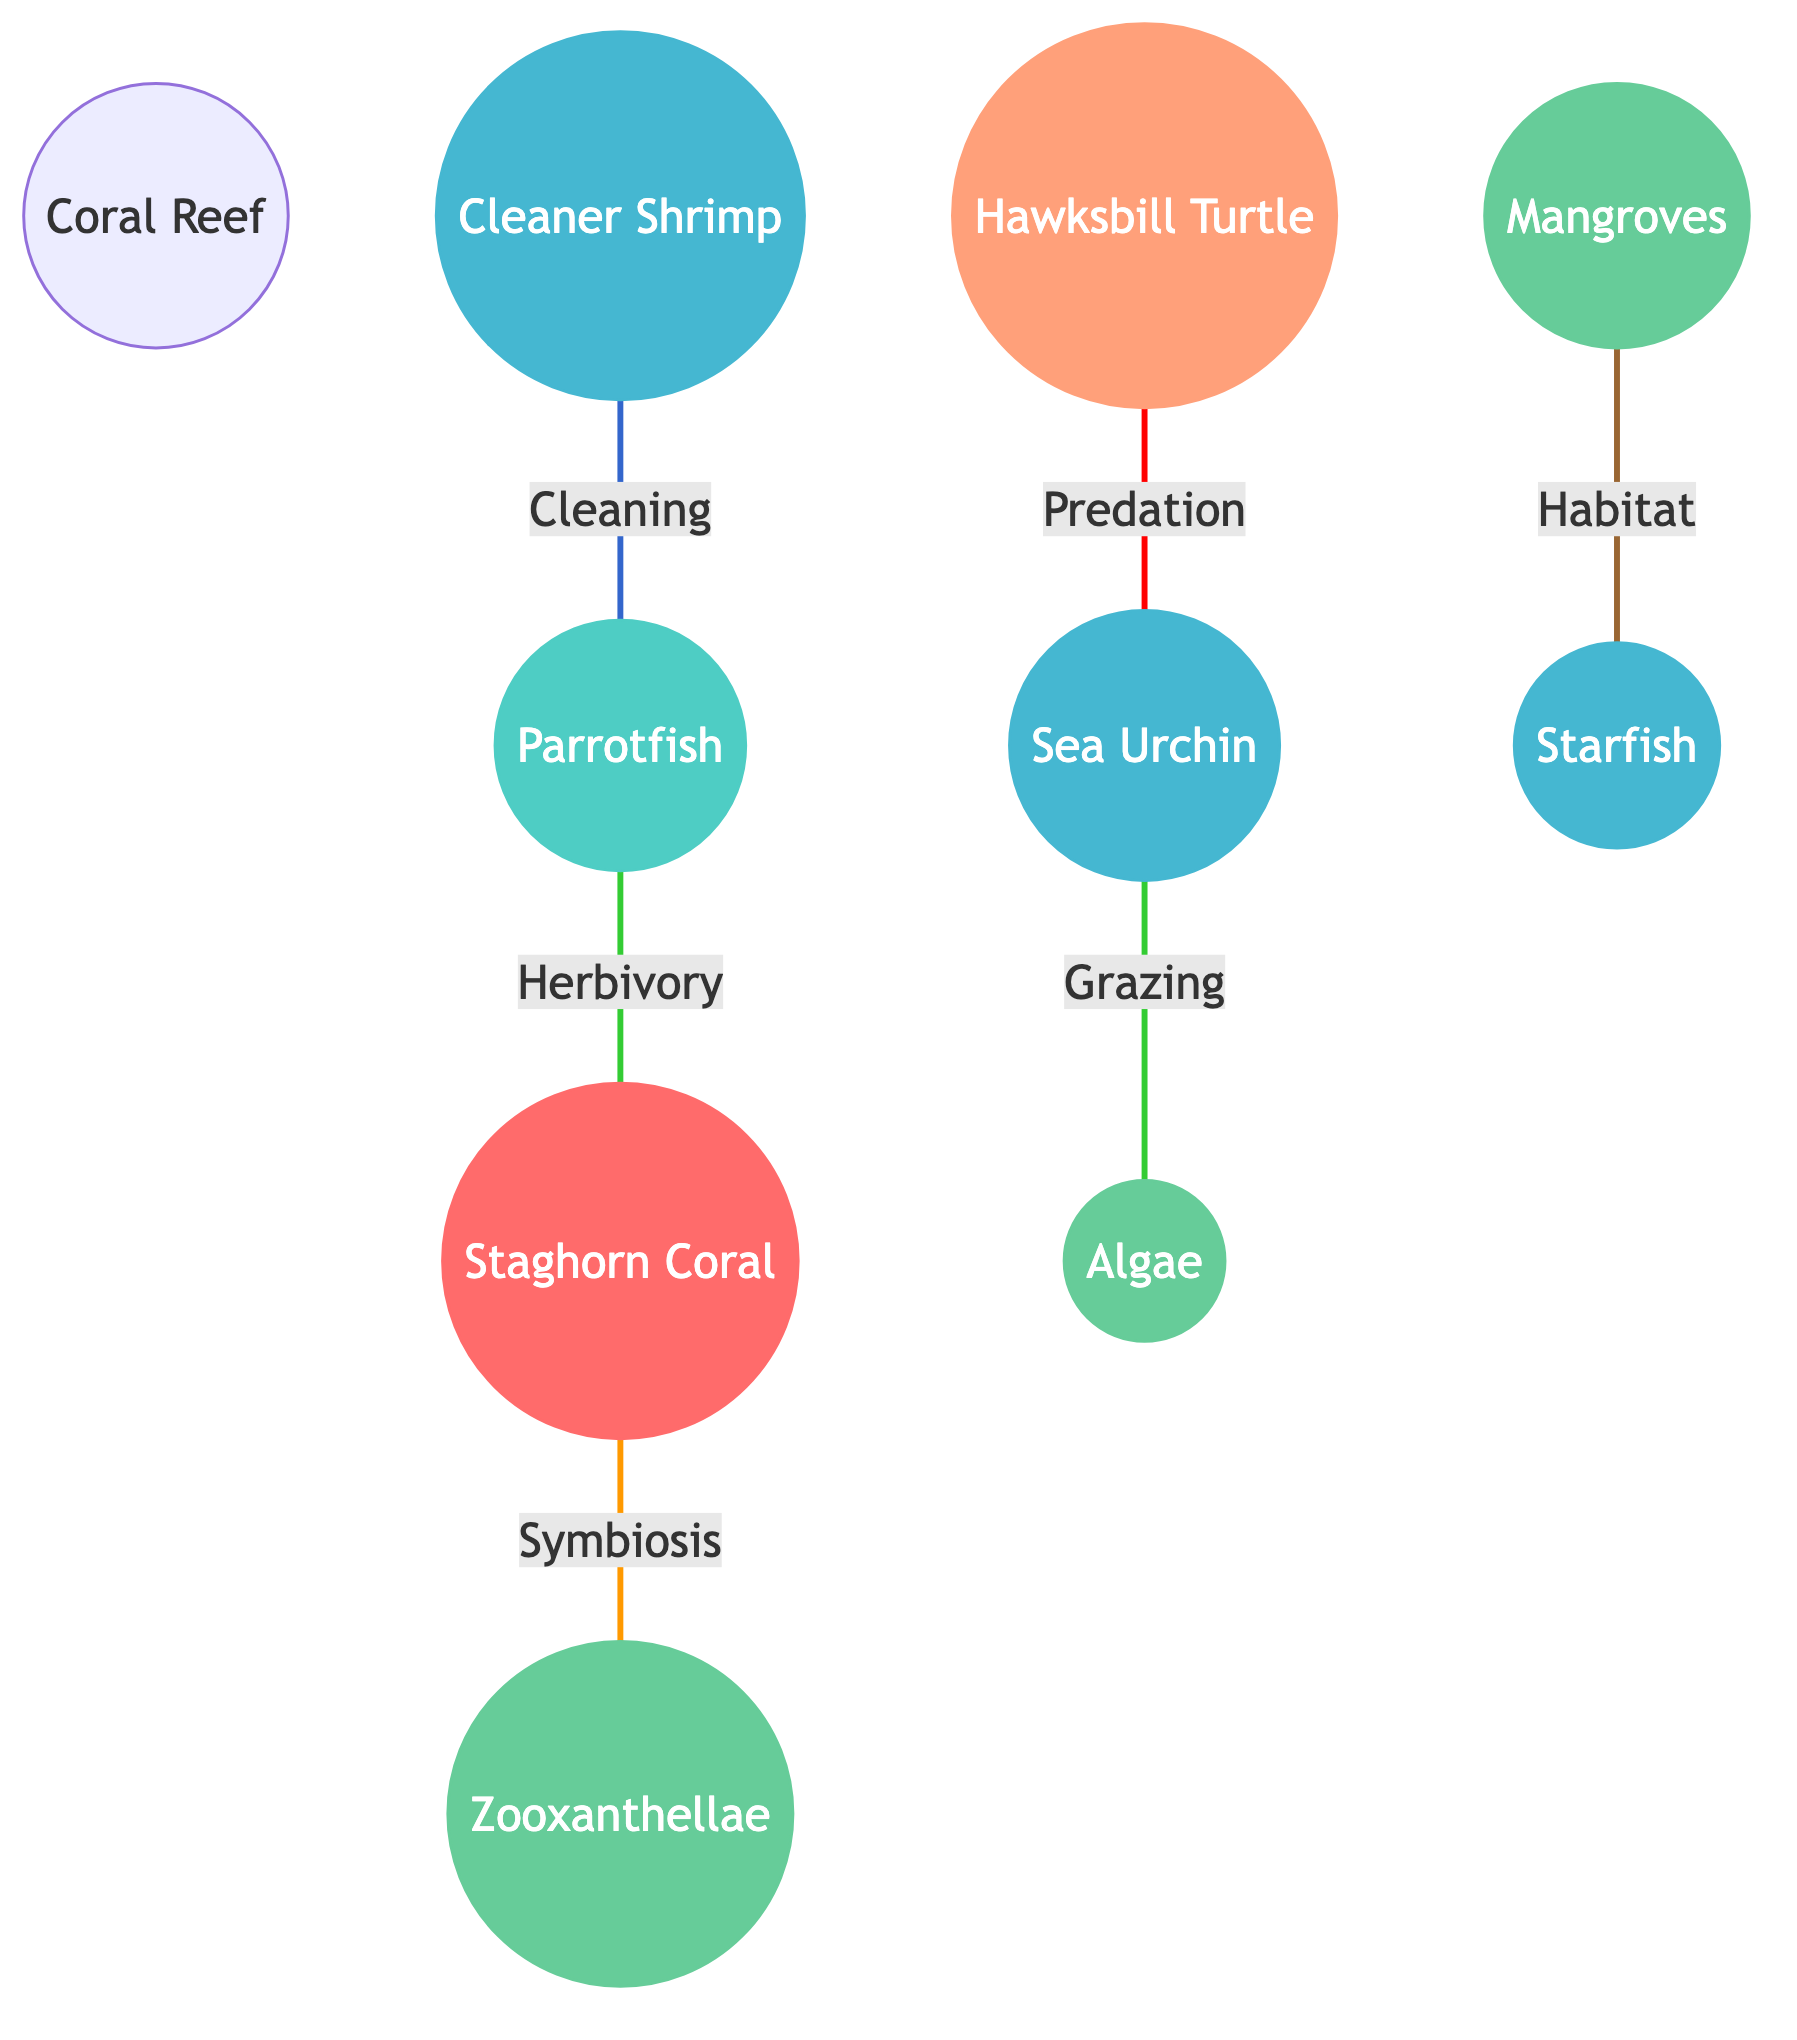What types of organisms are represented in the coral reef ecosystem? The diagram includes corals, fish, invertebrates, plants, and reptiles, indicating the diversity of organisms present in the coral reef ecosystem.
Answer: corals, fish, invertebrates, plants, reptiles How many primary plants are featured in the diagram? The diagram shows three primary plant species: Zooxanthellae, Mangroves, and Algae. By counting these nodes, we find there are three plants.
Answer: 3 What is the relationship between Staghorn Coral and Zooxanthellae? The diagram indicates that the relationship is Symbiosis. This connection highlights the mutual benefits gained by both the coral and the zooxanthellae.
Answer: Symbiosis Which organism preys on the Sea Urchin? The diagram shows the Hawksbill Turtle connected to the Sea Urchin through the relationship Predation, indicating that Hawksbill Turtles consume Sea Urchins.
Answer: Hawksbill Turtle How many total species interactions are depicted in the diagram? There are six interactions represented: Symbiosis, Herbivory, Grazing, Predation, Habitat, and Cleaning. By counting these connections from the various organisms, we confirm there are six interactions.
Answer: 6 What type of interaction do Cleaner Shrimp have with Parrotfish? The diagram illustrates the interaction as Cleaning, indicating that Cleaner Shrimp help Parrotfish by removing parasites or debris from their skin.
Answer: Cleaning Which organism is linked to Mangroves and for what purpose? The Starfish is linked to Mangroves with the relationship Habitat, indicating that mangroves provide a habitat for starfish to reside in.
Answer: Habitat What is the role of Parrotfish in relation to Staghorn Coral? The diagram specifies the role of Parrotfish as Herbivory, which means they feed on the Staghorn Coral, impacting coral health and growth.
Answer: Herbivory 